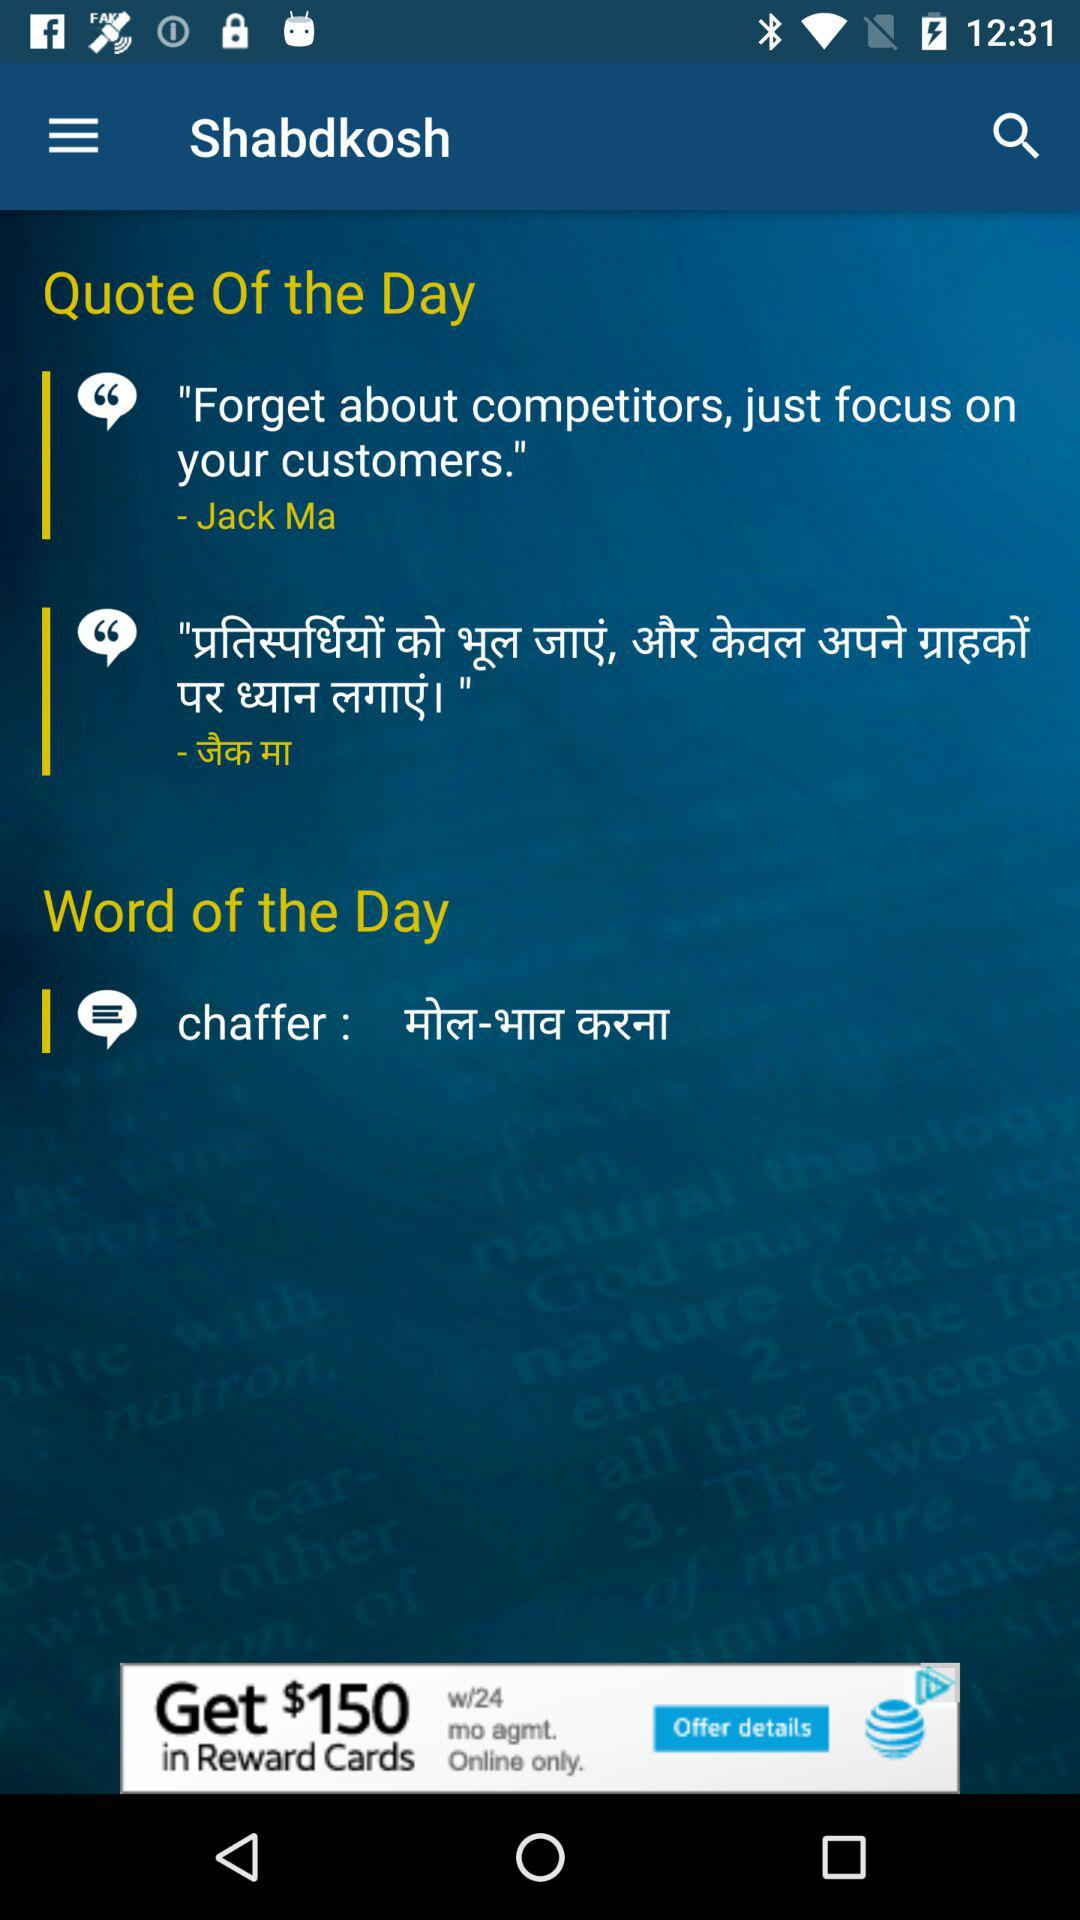What is the app's name? The app's name is "Shabdkosh". 